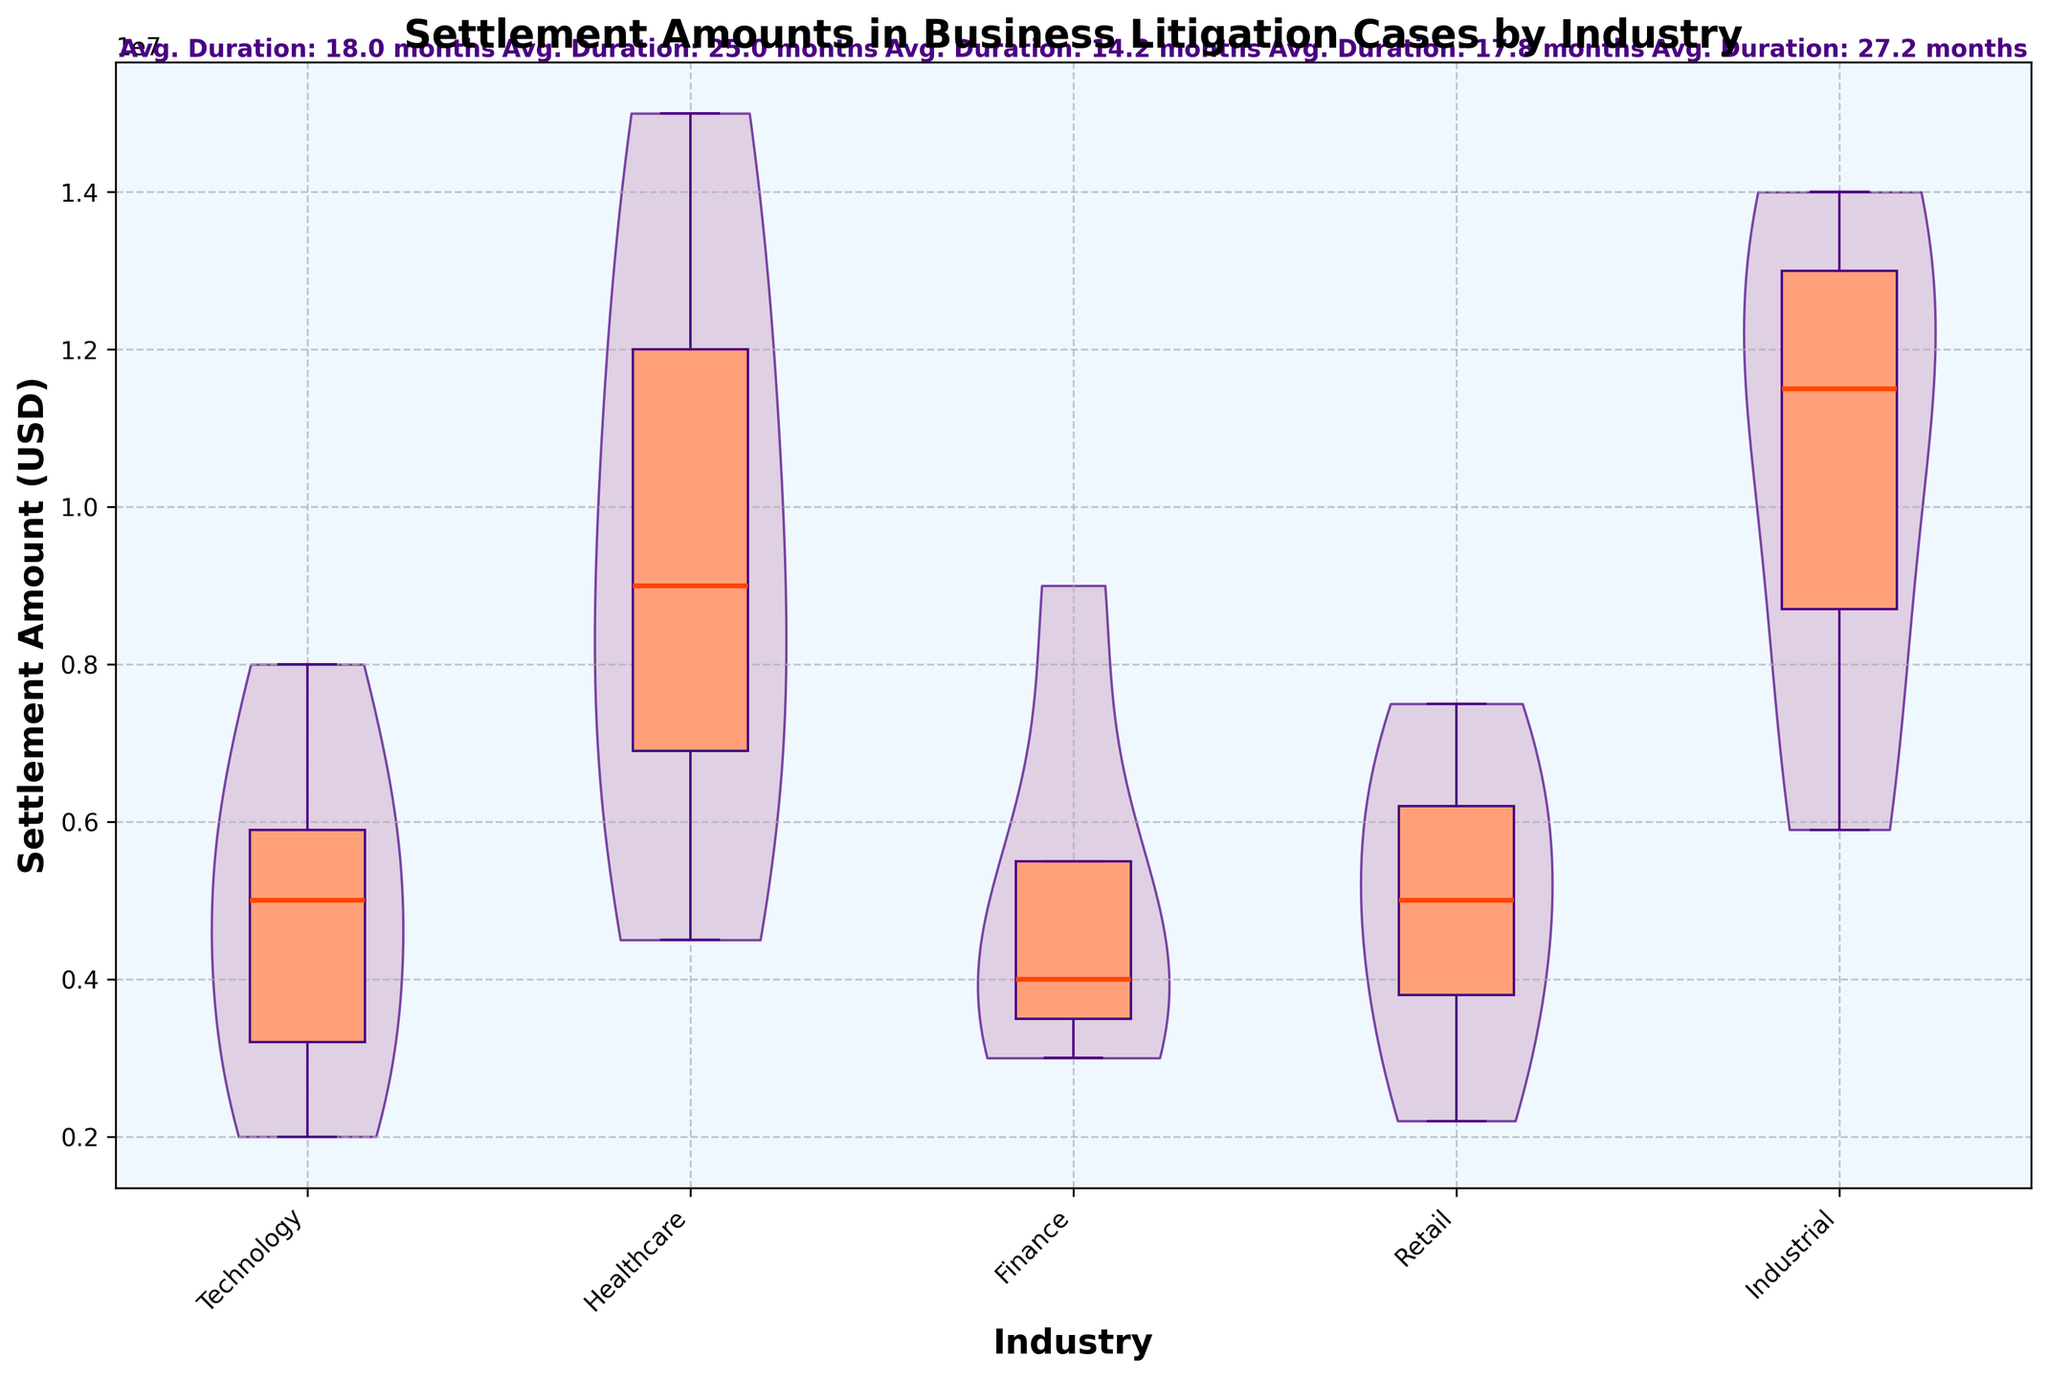What is the title of the figure? The title is usually located at the top of the figure where it summarizes the content being presented. In this case, it reads "Settlement Amounts in Business Litigation Cases by Industry".
Answer: Settlement Amounts in Business Litigation Cases by Industry What industries are included in the violin plot? The x-axis labels indicate the different industries analyzed in the figure. They are Technology, Healthcare, Finance, Retail, and Industrial.
Answer: Technology, Healthcare, Finance, Retail, Industrial What is the median settlement amount for the Healthcare industry? The median settlement amount is represented by an orange horizontal line inside the box plot for the Healthcare industry. Visually identifying this line within the Healthcare section will provide the answer.
Answer: $9000000 Which industry has the highest maximum settlement amount? By looking at the top of each box plot, we can identify the industry with the highest point. In this figure, the Industrial industry has the highest maximum settlement amount with a visible point above $14,000,000.
Answer: Industrial What is the average case duration for the Technology industry? The average case duration for each industry is indicated as text above the respective industry in the plot. For the Technology industry, this text shows "Avg. Duration: 18.0 months".
Answer: 18.0 months Which industry demonstrates the most variation in settlement amounts? To locate the industry with the most variation, look for the widest violin shape since the width of the violin plot represents the density of data. The Healthcare industry's violin plot appears to be the widest, implying the most variation.
Answer: Healthcare Compare the median settlement amounts between Technology and Retail. Which is higher? The orange horizontal lines in the box plots denote the medians. Comparing these within the Technology and Retail sections shows that Technology has a lower median than Retail.
Answer: Retail What industry has the smallest range of settlement amounts? The range in a box plot is determined by the distance between the top and bottom whiskers. The Finance industry has the shortest whiskers, indicating the smallest range of settlement amounts.
Answer: Finance What is the color used for the box plot elements in the figure? The elements of the box plot (boxes, whiskers, caps) are consistently colored. Referring to the plot, we see these elements are dark purple.
Answer: Dark purple How does the average case duration of Finance compare to that of Industrial? The average case durations are annotated above each industry. Finance has an average duration of 14.2 months, and Industrial has an average duration of 27.2 months. Thus, the duration is shorter in Finance compared to Industrial.
Answer: Shorter in Finance 